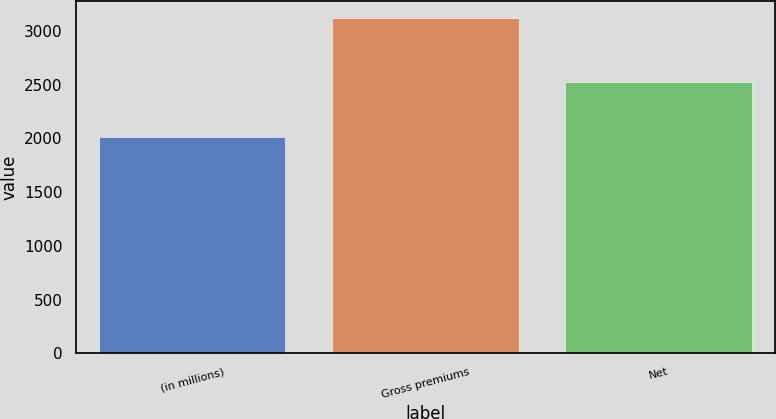Convert chart to OTSL. <chart><loc_0><loc_0><loc_500><loc_500><bar_chart><fcel>(in millions)<fcel>Gross premiums<fcel>Net<nl><fcel>2011<fcel>3121<fcel>2524<nl></chart> 